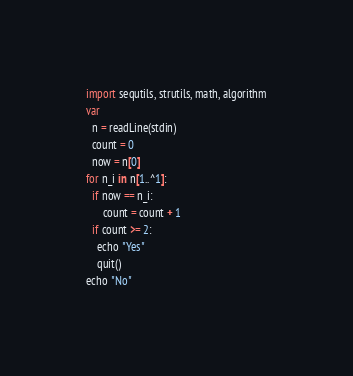<code> <loc_0><loc_0><loc_500><loc_500><_Nim_>import sequtils, strutils, math, algorithm
var
  n = readLine(stdin)
  count = 0
  now = n[0]
for n_i in n[1..^1]:
  if now == n_i:
      count = count + 1
  if count >= 2:
    echo "Yes"
    quit()
echo "No"</code> 